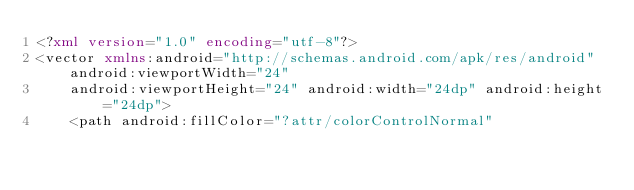<code> <loc_0><loc_0><loc_500><loc_500><_XML_><?xml version="1.0" encoding="utf-8"?>
<vector xmlns:android="http://schemas.android.com/apk/res/android" android:viewportWidth="24"
    android:viewportHeight="24" android:width="24dp" android:height="24dp">
    <path android:fillColor="?attr/colorControlNormal"</code> 